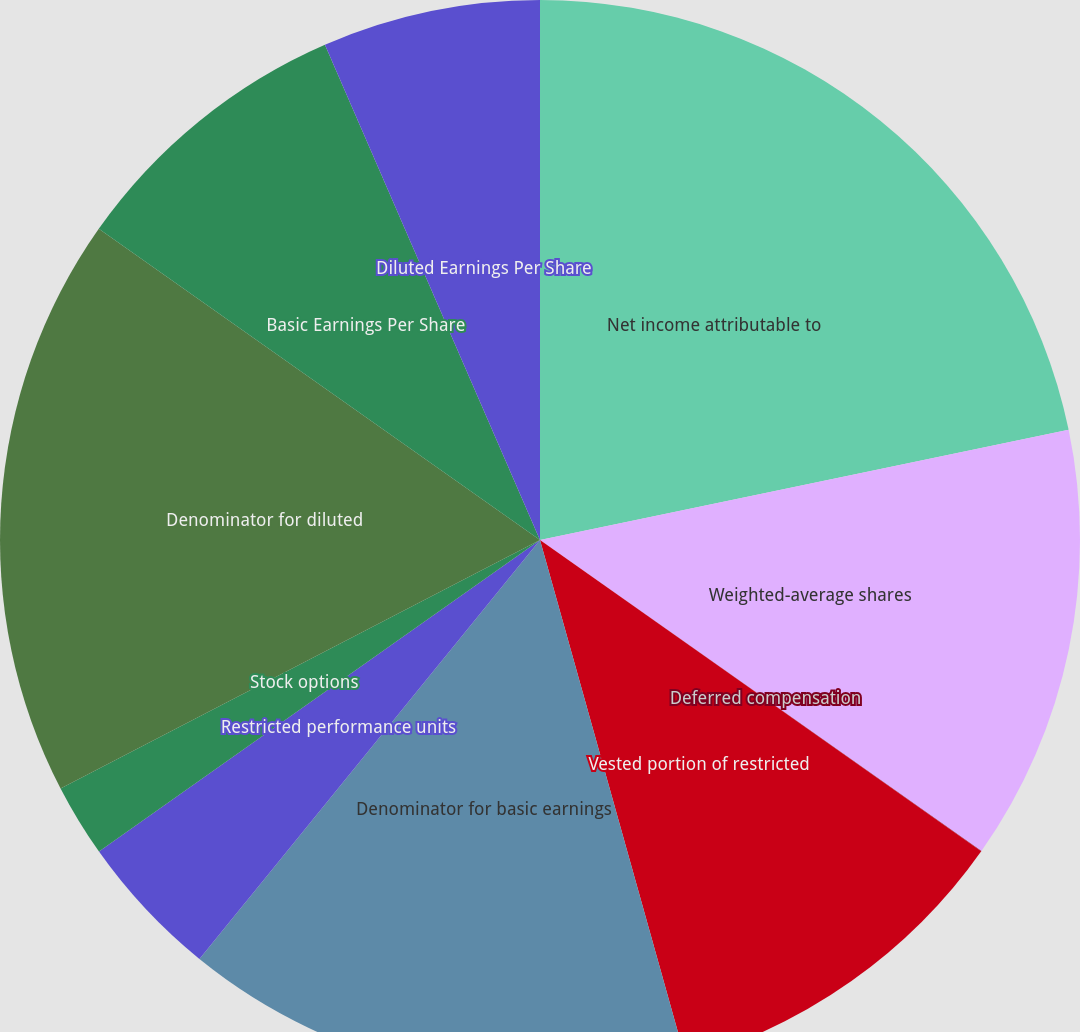Convert chart to OTSL. <chart><loc_0><loc_0><loc_500><loc_500><pie_chart><fcel>Net income attributable to<fcel>Weighted-average shares<fcel>Deferred compensation<fcel>Vested portion of restricted<fcel>Denominator for basic earnings<fcel>Restricted performance units<fcel>Stock options<fcel>Denominator for diluted<fcel>Basic Earnings Per Share<fcel>Diluted Earnings Per Share<nl><fcel>21.73%<fcel>13.04%<fcel>0.01%<fcel>10.87%<fcel>15.21%<fcel>4.35%<fcel>2.18%<fcel>17.39%<fcel>8.7%<fcel>6.52%<nl></chart> 